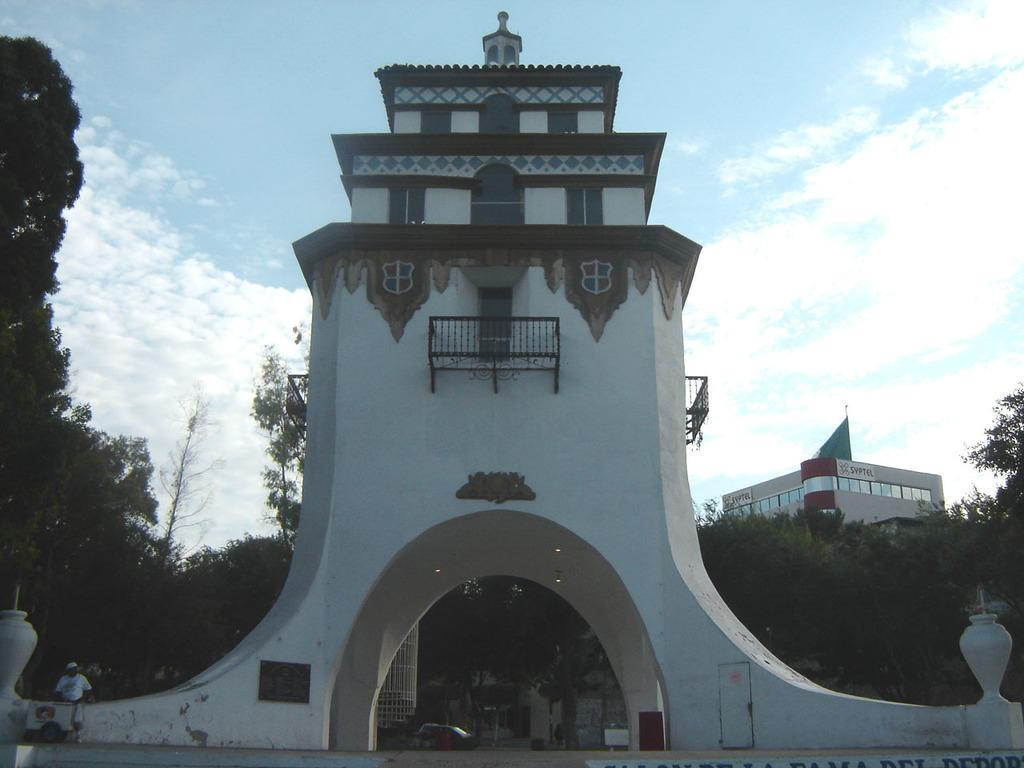What type of structure can be seen in the image? There is an arch wall in the image. Can you describe the person in the image? There is a person standing in the image. What is happening on the road in the image? Vehicles are moving on the road in the image. What type of vegetation is present in the image? There are trees in the image. What else can be seen in the image besides the arch wall and trees? There are buildings in the image. What is visible in the background of the image? The sky with clouds is visible in the background of the image. Where is the goose sitting in the image? There is no goose present in the image. What type of order is being followed by the person in the image? There is no indication of any order being followed by the person in the image. 